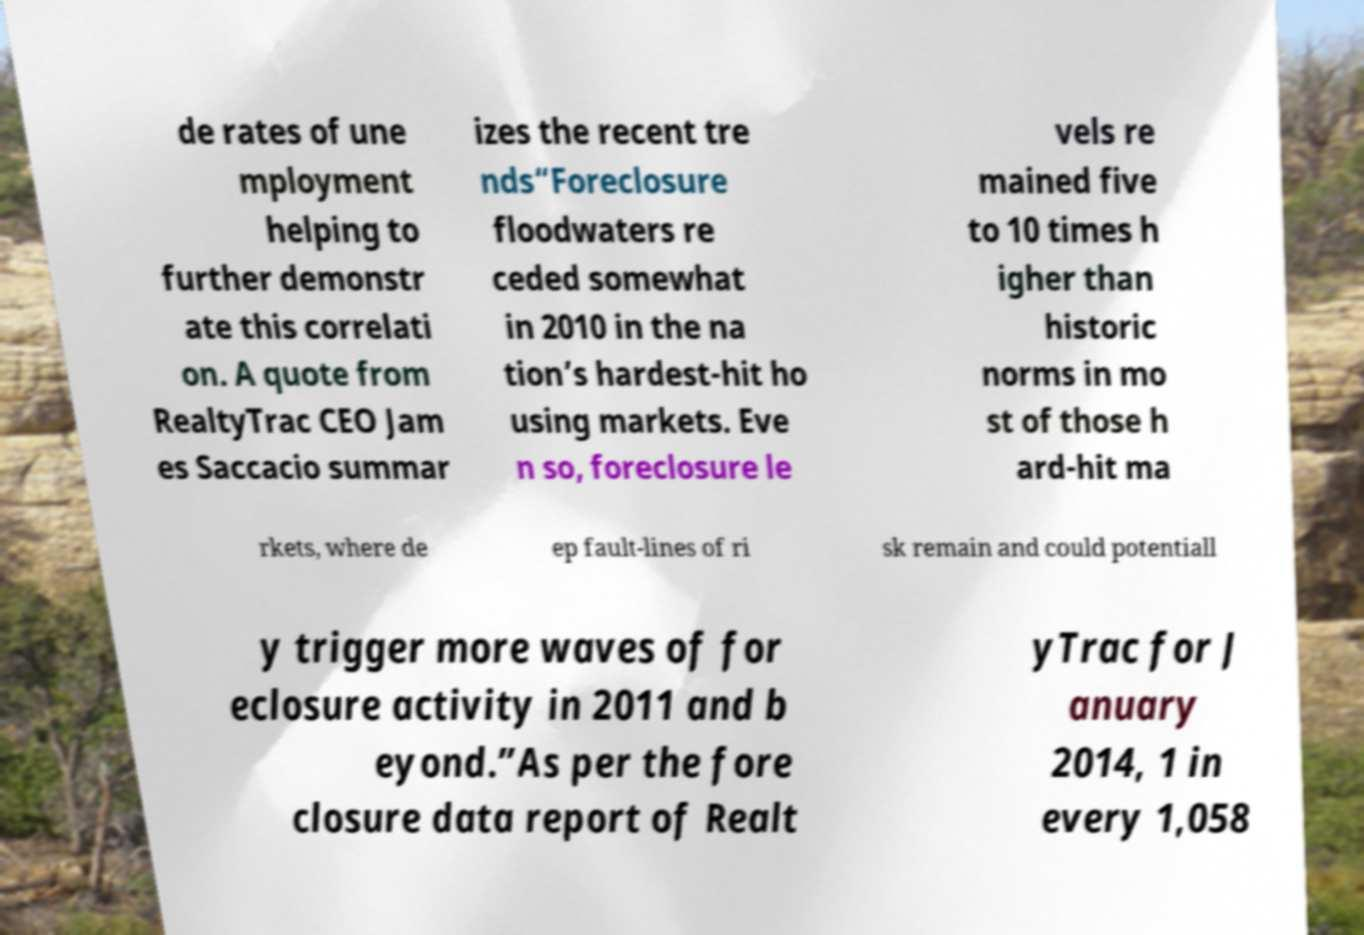I need the written content from this picture converted into text. Can you do that? de rates of une mployment helping to further demonstr ate this correlati on. A quote from RealtyTrac CEO Jam es Saccacio summar izes the recent tre nds“Foreclosure floodwaters re ceded somewhat in 2010 in the na tion’s hardest-hit ho using markets. Eve n so, foreclosure le vels re mained five to 10 times h igher than historic norms in mo st of those h ard-hit ma rkets, where de ep fault-lines of ri sk remain and could potentiall y trigger more waves of for eclosure activity in 2011 and b eyond.”As per the fore closure data report of Realt yTrac for J anuary 2014, 1 in every 1,058 